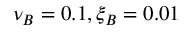<formula> <loc_0><loc_0><loc_500><loc_500>\nu _ { B } = 0 . 1 , \xi _ { B } = 0 . 0 1</formula> 